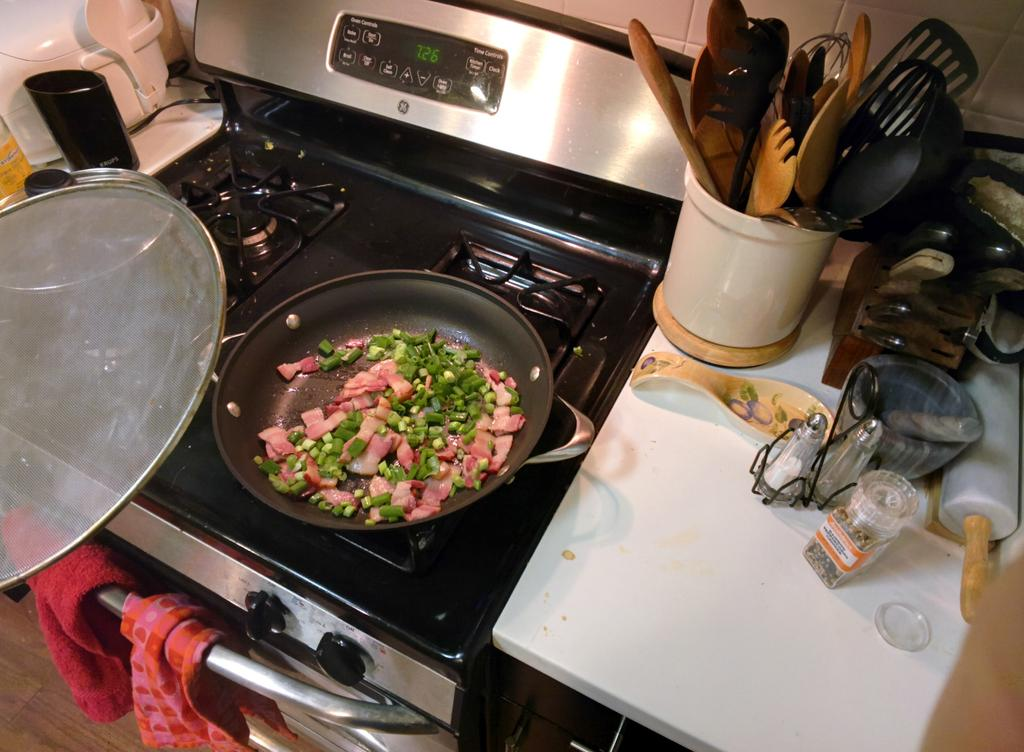<image>
Create a compact narrative representing the image presented. A stove with a clock that shows it is 7:26 at the moment 